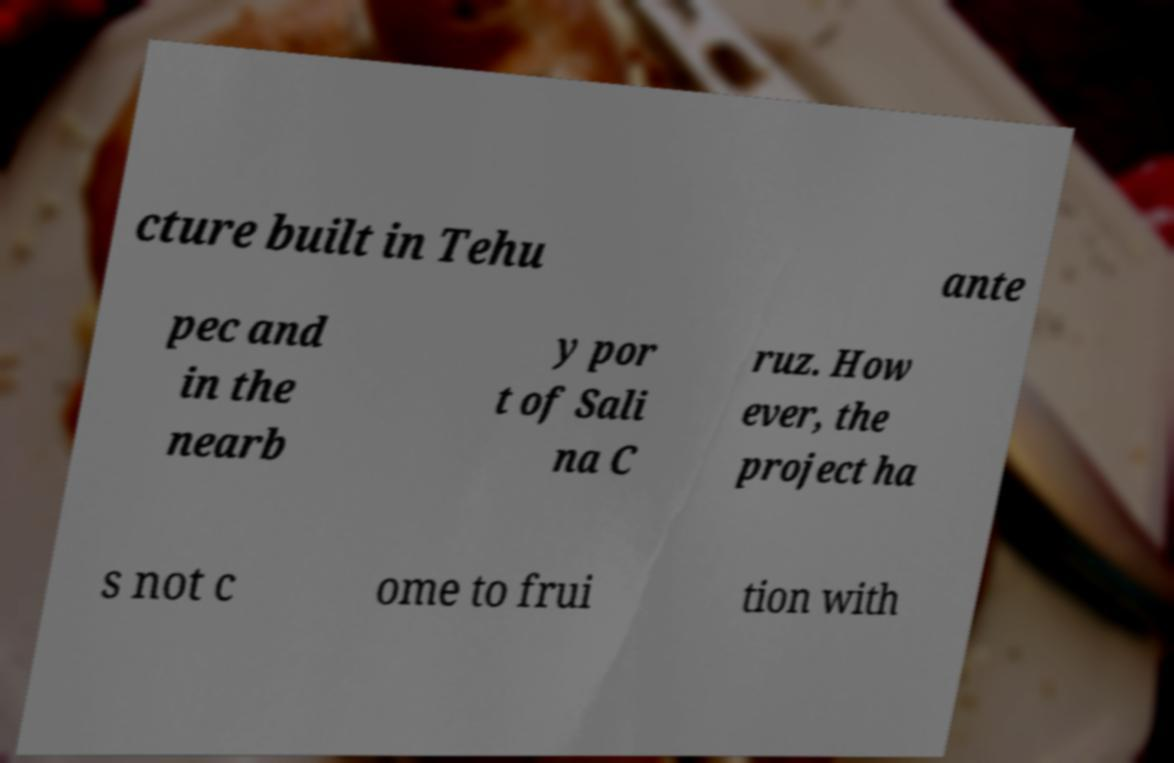Could you extract and type out the text from this image? cture built in Tehu ante pec and in the nearb y por t of Sali na C ruz. How ever, the project ha s not c ome to frui tion with 